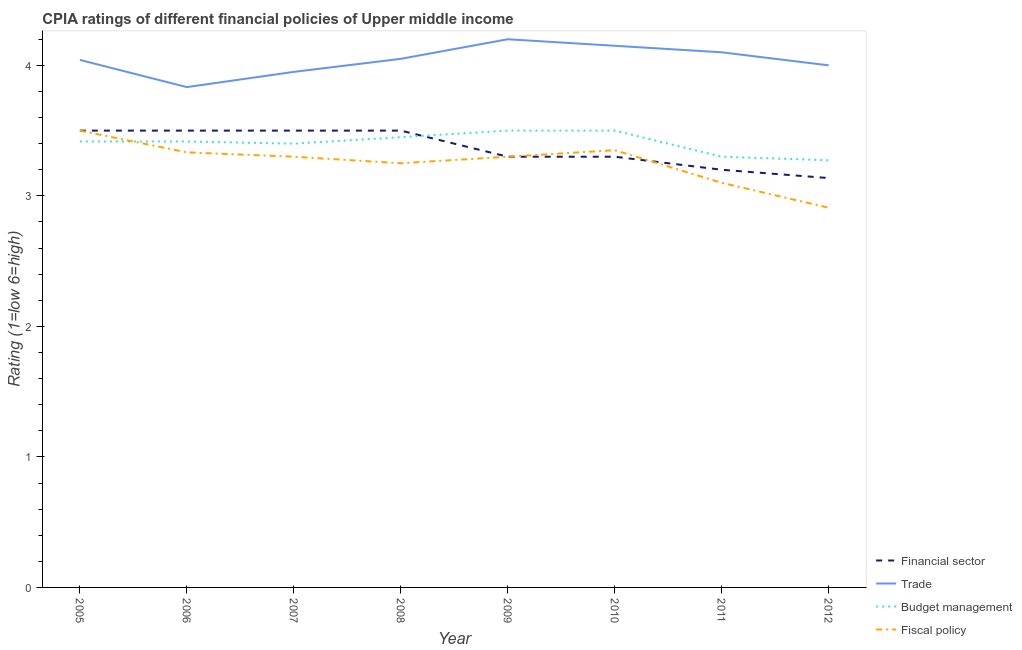Does the line corresponding to cpia rating of financial sector intersect with the line corresponding to cpia rating of budget management?
Your answer should be very brief. Yes. What is the cpia rating of fiscal policy in 2007?
Offer a very short reply. 3.3. Across all years, what is the maximum cpia rating of financial sector?
Your answer should be very brief. 3.5. Across all years, what is the minimum cpia rating of trade?
Make the answer very short. 3.83. What is the total cpia rating of budget management in the graph?
Your answer should be very brief. 27.26. What is the difference between the cpia rating of fiscal policy in 2010 and that in 2012?
Give a very brief answer. 0.44. What is the difference between the cpia rating of budget management in 2010 and the cpia rating of trade in 2008?
Your answer should be very brief. -0.55. What is the average cpia rating of financial sector per year?
Provide a short and direct response. 3.37. In the year 2010, what is the difference between the cpia rating of trade and cpia rating of financial sector?
Give a very brief answer. 0.85. In how many years, is the cpia rating of trade greater than 1.6?
Make the answer very short. 8. What is the ratio of the cpia rating of fiscal policy in 2005 to that in 2011?
Provide a succinct answer. 1.13. What is the difference between the highest and the second highest cpia rating of fiscal policy?
Your response must be concise. 0.15. What is the difference between the highest and the lowest cpia rating of fiscal policy?
Your response must be concise. 0.59. Is it the case that in every year, the sum of the cpia rating of financial sector and cpia rating of trade is greater than the cpia rating of budget management?
Your answer should be compact. Yes. Does the cpia rating of financial sector monotonically increase over the years?
Provide a succinct answer. No. How many lines are there?
Your answer should be very brief. 4. How many years are there in the graph?
Provide a succinct answer. 8. Where does the legend appear in the graph?
Your answer should be compact. Bottom right. How many legend labels are there?
Keep it short and to the point. 4. What is the title of the graph?
Keep it short and to the point. CPIA ratings of different financial policies of Upper middle income. What is the label or title of the X-axis?
Provide a succinct answer. Year. What is the Rating (1=low 6=high) in Trade in 2005?
Keep it short and to the point. 4.04. What is the Rating (1=low 6=high) in Budget management in 2005?
Offer a very short reply. 3.42. What is the Rating (1=low 6=high) in Trade in 2006?
Ensure brevity in your answer.  3.83. What is the Rating (1=low 6=high) in Budget management in 2006?
Provide a short and direct response. 3.42. What is the Rating (1=low 6=high) of Fiscal policy in 2006?
Give a very brief answer. 3.33. What is the Rating (1=low 6=high) in Financial sector in 2007?
Provide a short and direct response. 3.5. What is the Rating (1=low 6=high) in Trade in 2007?
Your response must be concise. 3.95. What is the Rating (1=low 6=high) in Budget management in 2007?
Provide a short and direct response. 3.4. What is the Rating (1=low 6=high) in Fiscal policy in 2007?
Keep it short and to the point. 3.3. What is the Rating (1=low 6=high) in Financial sector in 2008?
Offer a very short reply. 3.5. What is the Rating (1=low 6=high) in Trade in 2008?
Your answer should be very brief. 4.05. What is the Rating (1=low 6=high) in Budget management in 2008?
Make the answer very short. 3.45. What is the Rating (1=low 6=high) in Financial sector in 2010?
Provide a succinct answer. 3.3. What is the Rating (1=low 6=high) of Trade in 2010?
Offer a terse response. 4.15. What is the Rating (1=low 6=high) in Fiscal policy in 2010?
Keep it short and to the point. 3.35. What is the Rating (1=low 6=high) in Fiscal policy in 2011?
Your answer should be very brief. 3.1. What is the Rating (1=low 6=high) of Financial sector in 2012?
Provide a short and direct response. 3.14. What is the Rating (1=low 6=high) in Trade in 2012?
Keep it short and to the point. 4. What is the Rating (1=low 6=high) of Budget management in 2012?
Offer a very short reply. 3.27. What is the Rating (1=low 6=high) in Fiscal policy in 2012?
Your answer should be compact. 2.91. Across all years, what is the maximum Rating (1=low 6=high) of Trade?
Your response must be concise. 4.2. Across all years, what is the minimum Rating (1=low 6=high) of Financial sector?
Offer a very short reply. 3.14. Across all years, what is the minimum Rating (1=low 6=high) of Trade?
Your answer should be compact. 3.83. Across all years, what is the minimum Rating (1=low 6=high) of Budget management?
Provide a succinct answer. 3.27. Across all years, what is the minimum Rating (1=low 6=high) in Fiscal policy?
Your answer should be very brief. 2.91. What is the total Rating (1=low 6=high) in Financial sector in the graph?
Your answer should be very brief. 26.94. What is the total Rating (1=low 6=high) of Trade in the graph?
Provide a succinct answer. 32.33. What is the total Rating (1=low 6=high) in Budget management in the graph?
Offer a terse response. 27.26. What is the total Rating (1=low 6=high) in Fiscal policy in the graph?
Your answer should be compact. 26.04. What is the difference between the Rating (1=low 6=high) of Trade in 2005 and that in 2006?
Provide a succinct answer. 0.21. What is the difference between the Rating (1=low 6=high) in Budget management in 2005 and that in 2006?
Your response must be concise. 0. What is the difference between the Rating (1=low 6=high) in Fiscal policy in 2005 and that in 2006?
Your response must be concise. 0.17. What is the difference between the Rating (1=low 6=high) of Financial sector in 2005 and that in 2007?
Offer a terse response. 0. What is the difference between the Rating (1=low 6=high) of Trade in 2005 and that in 2007?
Ensure brevity in your answer.  0.09. What is the difference between the Rating (1=low 6=high) in Budget management in 2005 and that in 2007?
Provide a succinct answer. 0.02. What is the difference between the Rating (1=low 6=high) of Fiscal policy in 2005 and that in 2007?
Offer a very short reply. 0.2. What is the difference between the Rating (1=low 6=high) of Trade in 2005 and that in 2008?
Your answer should be compact. -0.01. What is the difference between the Rating (1=low 6=high) in Budget management in 2005 and that in 2008?
Ensure brevity in your answer.  -0.03. What is the difference between the Rating (1=low 6=high) in Financial sector in 2005 and that in 2009?
Your answer should be compact. 0.2. What is the difference between the Rating (1=low 6=high) of Trade in 2005 and that in 2009?
Offer a very short reply. -0.16. What is the difference between the Rating (1=low 6=high) of Budget management in 2005 and that in 2009?
Your answer should be very brief. -0.08. What is the difference between the Rating (1=low 6=high) in Trade in 2005 and that in 2010?
Your response must be concise. -0.11. What is the difference between the Rating (1=low 6=high) of Budget management in 2005 and that in 2010?
Make the answer very short. -0.08. What is the difference between the Rating (1=low 6=high) of Financial sector in 2005 and that in 2011?
Make the answer very short. 0.3. What is the difference between the Rating (1=low 6=high) in Trade in 2005 and that in 2011?
Your answer should be very brief. -0.06. What is the difference between the Rating (1=low 6=high) in Budget management in 2005 and that in 2011?
Provide a succinct answer. 0.12. What is the difference between the Rating (1=low 6=high) in Fiscal policy in 2005 and that in 2011?
Your response must be concise. 0.4. What is the difference between the Rating (1=low 6=high) in Financial sector in 2005 and that in 2012?
Offer a terse response. 0.36. What is the difference between the Rating (1=low 6=high) in Trade in 2005 and that in 2012?
Offer a very short reply. 0.04. What is the difference between the Rating (1=low 6=high) in Budget management in 2005 and that in 2012?
Your answer should be compact. 0.14. What is the difference between the Rating (1=low 6=high) in Fiscal policy in 2005 and that in 2012?
Provide a succinct answer. 0.59. What is the difference between the Rating (1=low 6=high) of Trade in 2006 and that in 2007?
Offer a very short reply. -0.12. What is the difference between the Rating (1=low 6=high) of Budget management in 2006 and that in 2007?
Offer a terse response. 0.02. What is the difference between the Rating (1=low 6=high) of Fiscal policy in 2006 and that in 2007?
Give a very brief answer. 0.03. What is the difference between the Rating (1=low 6=high) of Financial sector in 2006 and that in 2008?
Offer a terse response. 0. What is the difference between the Rating (1=low 6=high) in Trade in 2006 and that in 2008?
Offer a terse response. -0.22. What is the difference between the Rating (1=low 6=high) of Budget management in 2006 and that in 2008?
Your answer should be compact. -0.03. What is the difference between the Rating (1=low 6=high) of Fiscal policy in 2006 and that in 2008?
Offer a very short reply. 0.08. What is the difference between the Rating (1=low 6=high) of Financial sector in 2006 and that in 2009?
Give a very brief answer. 0.2. What is the difference between the Rating (1=low 6=high) in Trade in 2006 and that in 2009?
Your answer should be very brief. -0.37. What is the difference between the Rating (1=low 6=high) of Budget management in 2006 and that in 2009?
Make the answer very short. -0.08. What is the difference between the Rating (1=low 6=high) in Financial sector in 2006 and that in 2010?
Keep it short and to the point. 0.2. What is the difference between the Rating (1=low 6=high) of Trade in 2006 and that in 2010?
Your answer should be compact. -0.32. What is the difference between the Rating (1=low 6=high) of Budget management in 2006 and that in 2010?
Your answer should be very brief. -0.08. What is the difference between the Rating (1=low 6=high) in Fiscal policy in 2006 and that in 2010?
Keep it short and to the point. -0.02. What is the difference between the Rating (1=low 6=high) in Financial sector in 2006 and that in 2011?
Offer a terse response. 0.3. What is the difference between the Rating (1=low 6=high) of Trade in 2006 and that in 2011?
Give a very brief answer. -0.27. What is the difference between the Rating (1=low 6=high) of Budget management in 2006 and that in 2011?
Offer a very short reply. 0.12. What is the difference between the Rating (1=low 6=high) in Fiscal policy in 2006 and that in 2011?
Your answer should be very brief. 0.23. What is the difference between the Rating (1=low 6=high) in Financial sector in 2006 and that in 2012?
Your answer should be compact. 0.36. What is the difference between the Rating (1=low 6=high) of Trade in 2006 and that in 2012?
Your response must be concise. -0.17. What is the difference between the Rating (1=low 6=high) of Budget management in 2006 and that in 2012?
Offer a very short reply. 0.14. What is the difference between the Rating (1=low 6=high) in Fiscal policy in 2006 and that in 2012?
Your answer should be very brief. 0.42. What is the difference between the Rating (1=low 6=high) in Financial sector in 2007 and that in 2008?
Make the answer very short. 0. What is the difference between the Rating (1=low 6=high) in Budget management in 2007 and that in 2008?
Your answer should be compact. -0.05. What is the difference between the Rating (1=low 6=high) in Financial sector in 2007 and that in 2009?
Ensure brevity in your answer.  0.2. What is the difference between the Rating (1=low 6=high) in Budget management in 2007 and that in 2009?
Keep it short and to the point. -0.1. What is the difference between the Rating (1=low 6=high) of Financial sector in 2007 and that in 2010?
Your answer should be very brief. 0.2. What is the difference between the Rating (1=low 6=high) of Trade in 2007 and that in 2010?
Offer a terse response. -0.2. What is the difference between the Rating (1=low 6=high) of Financial sector in 2007 and that in 2011?
Your response must be concise. 0.3. What is the difference between the Rating (1=low 6=high) in Trade in 2007 and that in 2011?
Your answer should be very brief. -0.15. What is the difference between the Rating (1=low 6=high) in Fiscal policy in 2007 and that in 2011?
Provide a succinct answer. 0.2. What is the difference between the Rating (1=low 6=high) in Financial sector in 2007 and that in 2012?
Offer a very short reply. 0.36. What is the difference between the Rating (1=low 6=high) of Trade in 2007 and that in 2012?
Ensure brevity in your answer.  -0.05. What is the difference between the Rating (1=low 6=high) of Budget management in 2007 and that in 2012?
Offer a very short reply. 0.13. What is the difference between the Rating (1=low 6=high) in Fiscal policy in 2007 and that in 2012?
Your answer should be compact. 0.39. What is the difference between the Rating (1=low 6=high) in Financial sector in 2008 and that in 2009?
Make the answer very short. 0.2. What is the difference between the Rating (1=low 6=high) in Trade in 2008 and that in 2009?
Your answer should be compact. -0.15. What is the difference between the Rating (1=low 6=high) in Fiscal policy in 2008 and that in 2009?
Your response must be concise. -0.05. What is the difference between the Rating (1=low 6=high) in Financial sector in 2008 and that in 2010?
Ensure brevity in your answer.  0.2. What is the difference between the Rating (1=low 6=high) of Budget management in 2008 and that in 2010?
Keep it short and to the point. -0.05. What is the difference between the Rating (1=low 6=high) in Fiscal policy in 2008 and that in 2010?
Make the answer very short. -0.1. What is the difference between the Rating (1=low 6=high) in Financial sector in 2008 and that in 2011?
Offer a very short reply. 0.3. What is the difference between the Rating (1=low 6=high) in Trade in 2008 and that in 2011?
Offer a terse response. -0.05. What is the difference between the Rating (1=low 6=high) in Budget management in 2008 and that in 2011?
Ensure brevity in your answer.  0.15. What is the difference between the Rating (1=low 6=high) in Fiscal policy in 2008 and that in 2011?
Your answer should be compact. 0.15. What is the difference between the Rating (1=low 6=high) in Financial sector in 2008 and that in 2012?
Provide a short and direct response. 0.36. What is the difference between the Rating (1=low 6=high) of Budget management in 2008 and that in 2012?
Ensure brevity in your answer.  0.18. What is the difference between the Rating (1=low 6=high) in Fiscal policy in 2008 and that in 2012?
Your answer should be very brief. 0.34. What is the difference between the Rating (1=low 6=high) of Financial sector in 2009 and that in 2010?
Your answer should be compact. 0. What is the difference between the Rating (1=low 6=high) of Budget management in 2009 and that in 2010?
Ensure brevity in your answer.  0. What is the difference between the Rating (1=low 6=high) of Fiscal policy in 2009 and that in 2010?
Provide a succinct answer. -0.05. What is the difference between the Rating (1=low 6=high) in Fiscal policy in 2009 and that in 2011?
Ensure brevity in your answer.  0.2. What is the difference between the Rating (1=low 6=high) of Financial sector in 2009 and that in 2012?
Provide a short and direct response. 0.16. What is the difference between the Rating (1=low 6=high) of Trade in 2009 and that in 2012?
Your answer should be very brief. 0.2. What is the difference between the Rating (1=low 6=high) of Budget management in 2009 and that in 2012?
Your answer should be compact. 0.23. What is the difference between the Rating (1=low 6=high) in Fiscal policy in 2009 and that in 2012?
Ensure brevity in your answer.  0.39. What is the difference between the Rating (1=low 6=high) in Financial sector in 2010 and that in 2011?
Give a very brief answer. 0.1. What is the difference between the Rating (1=low 6=high) in Trade in 2010 and that in 2011?
Offer a very short reply. 0.05. What is the difference between the Rating (1=low 6=high) in Budget management in 2010 and that in 2011?
Give a very brief answer. 0.2. What is the difference between the Rating (1=low 6=high) of Fiscal policy in 2010 and that in 2011?
Give a very brief answer. 0.25. What is the difference between the Rating (1=low 6=high) in Financial sector in 2010 and that in 2012?
Ensure brevity in your answer.  0.16. What is the difference between the Rating (1=low 6=high) in Trade in 2010 and that in 2012?
Your answer should be very brief. 0.15. What is the difference between the Rating (1=low 6=high) in Budget management in 2010 and that in 2012?
Keep it short and to the point. 0.23. What is the difference between the Rating (1=low 6=high) in Fiscal policy in 2010 and that in 2012?
Your response must be concise. 0.44. What is the difference between the Rating (1=low 6=high) of Financial sector in 2011 and that in 2012?
Give a very brief answer. 0.06. What is the difference between the Rating (1=low 6=high) of Trade in 2011 and that in 2012?
Provide a succinct answer. 0.1. What is the difference between the Rating (1=low 6=high) in Budget management in 2011 and that in 2012?
Your response must be concise. 0.03. What is the difference between the Rating (1=low 6=high) of Fiscal policy in 2011 and that in 2012?
Provide a short and direct response. 0.19. What is the difference between the Rating (1=low 6=high) of Financial sector in 2005 and the Rating (1=low 6=high) of Trade in 2006?
Provide a short and direct response. -0.33. What is the difference between the Rating (1=low 6=high) of Financial sector in 2005 and the Rating (1=low 6=high) of Budget management in 2006?
Keep it short and to the point. 0.08. What is the difference between the Rating (1=low 6=high) in Financial sector in 2005 and the Rating (1=low 6=high) in Fiscal policy in 2006?
Ensure brevity in your answer.  0.17. What is the difference between the Rating (1=low 6=high) of Trade in 2005 and the Rating (1=low 6=high) of Fiscal policy in 2006?
Offer a very short reply. 0.71. What is the difference between the Rating (1=low 6=high) in Budget management in 2005 and the Rating (1=low 6=high) in Fiscal policy in 2006?
Give a very brief answer. 0.08. What is the difference between the Rating (1=low 6=high) in Financial sector in 2005 and the Rating (1=low 6=high) in Trade in 2007?
Offer a very short reply. -0.45. What is the difference between the Rating (1=low 6=high) of Trade in 2005 and the Rating (1=low 6=high) of Budget management in 2007?
Your answer should be very brief. 0.64. What is the difference between the Rating (1=low 6=high) in Trade in 2005 and the Rating (1=low 6=high) in Fiscal policy in 2007?
Your answer should be very brief. 0.74. What is the difference between the Rating (1=low 6=high) of Budget management in 2005 and the Rating (1=low 6=high) of Fiscal policy in 2007?
Offer a terse response. 0.12. What is the difference between the Rating (1=low 6=high) of Financial sector in 2005 and the Rating (1=low 6=high) of Trade in 2008?
Offer a terse response. -0.55. What is the difference between the Rating (1=low 6=high) in Financial sector in 2005 and the Rating (1=low 6=high) in Budget management in 2008?
Provide a short and direct response. 0.05. What is the difference between the Rating (1=low 6=high) of Trade in 2005 and the Rating (1=low 6=high) of Budget management in 2008?
Ensure brevity in your answer.  0.59. What is the difference between the Rating (1=low 6=high) of Trade in 2005 and the Rating (1=low 6=high) of Fiscal policy in 2008?
Your answer should be compact. 0.79. What is the difference between the Rating (1=low 6=high) in Budget management in 2005 and the Rating (1=low 6=high) in Fiscal policy in 2008?
Provide a succinct answer. 0.17. What is the difference between the Rating (1=low 6=high) in Financial sector in 2005 and the Rating (1=low 6=high) in Trade in 2009?
Keep it short and to the point. -0.7. What is the difference between the Rating (1=low 6=high) in Trade in 2005 and the Rating (1=low 6=high) in Budget management in 2009?
Keep it short and to the point. 0.54. What is the difference between the Rating (1=low 6=high) in Trade in 2005 and the Rating (1=low 6=high) in Fiscal policy in 2009?
Keep it short and to the point. 0.74. What is the difference between the Rating (1=low 6=high) in Budget management in 2005 and the Rating (1=low 6=high) in Fiscal policy in 2009?
Provide a short and direct response. 0.12. What is the difference between the Rating (1=low 6=high) of Financial sector in 2005 and the Rating (1=low 6=high) of Trade in 2010?
Provide a succinct answer. -0.65. What is the difference between the Rating (1=low 6=high) of Financial sector in 2005 and the Rating (1=low 6=high) of Fiscal policy in 2010?
Keep it short and to the point. 0.15. What is the difference between the Rating (1=low 6=high) of Trade in 2005 and the Rating (1=low 6=high) of Budget management in 2010?
Offer a very short reply. 0.54. What is the difference between the Rating (1=low 6=high) in Trade in 2005 and the Rating (1=low 6=high) in Fiscal policy in 2010?
Offer a terse response. 0.69. What is the difference between the Rating (1=low 6=high) in Budget management in 2005 and the Rating (1=low 6=high) in Fiscal policy in 2010?
Your answer should be compact. 0.07. What is the difference between the Rating (1=low 6=high) of Financial sector in 2005 and the Rating (1=low 6=high) of Trade in 2011?
Ensure brevity in your answer.  -0.6. What is the difference between the Rating (1=low 6=high) of Financial sector in 2005 and the Rating (1=low 6=high) of Budget management in 2011?
Make the answer very short. 0.2. What is the difference between the Rating (1=low 6=high) in Trade in 2005 and the Rating (1=low 6=high) in Budget management in 2011?
Provide a succinct answer. 0.74. What is the difference between the Rating (1=low 6=high) in Trade in 2005 and the Rating (1=low 6=high) in Fiscal policy in 2011?
Ensure brevity in your answer.  0.94. What is the difference between the Rating (1=low 6=high) in Budget management in 2005 and the Rating (1=low 6=high) in Fiscal policy in 2011?
Offer a terse response. 0.32. What is the difference between the Rating (1=low 6=high) of Financial sector in 2005 and the Rating (1=low 6=high) of Budget management in 2012?
Offer a terse response. 0.23. What is the difference between the Rating (1=low 6=high) of Financial sector in 2005 and the Rating (1=low 6=high) of Fiscal policy in 2012?
Offer a terse response. 0.59. What is the difference between the Rating (1=low 6=high) in Trade in 2005 and the Rating (1=low 6=high) in Budget management in 2012?
Offer a very short reply. 0.77. What is the difference between the Rating (1=low 6=high) in Trade in 2005 and the Rating (1=low 6=high) in Fiscal policy in 2012?
Ensure brevity in your answer.  1.13. What is the difference between the Rating (1=low 6=high) in Budget management in 2005 and the Rating (1=low 6=high) in Fiscal policy in 2012?
Offer a terse response. 0.51. What is the difference between the Rating (1=low 6=high) of Financial sector in 2006 and the Rating (1=low 6=high) of Trade in 2007?
Your response must be concise. -0.45. What is the difference between the Rating (1=low 6=high) of Financial sector in 2006 and the Rating (1=low 6=high) of Fiscal policy in 2007?
Offer a very short reply. 0.2. What is the difference between the Rating (1=low 6=high) in Trade in 2006 and the Rating (1=low 6=high) in Budget management in 2007?
Keep it short and to the point. 0.43. What is the difference between the Rating (1=low 6=high) in Trade in 2006 and the Rating (1=low 6=high) in Fiscal policy in 2007?
Keep it short and to the point. 0.53. What is the difference between the Rating (1=low 6=high) in Budget management in 2006 and the Rating (1=low 6=high) in Fiscal policy in 2007?
Your response must be concise. 0.12. What is the difference between the Rating (1=low 6=high) in Financial sector in 2006 and the Rating (1=low 6=high) in Trade in 2008?
Keep it short and to the point. -0.55. What is the difference between the Rating (1=low 6=high) of Trade in 2006 and the Rating (1=low 6=high) of Budget management in 2008?
Give a very brief answer. 0.38. What is the difference between the Rating (1=low 6=high) of Trade in 2006 and the Rating (1=low 6=high) of Fiscal policy in 2008?
Make the answer very short. 0.58. What is the difference between the Rating (1=low 6=high) of Budget management in 2006 and the Rating (1=low 6=high) of Fiscal policy in 2008?
Ensure brevity in your answer.  0.17. What is the difference between the Rating (1=low 6=high) of Financial sector in 2006 and the Rating (1=low 6=high) of Fiscal policy in 2009?
Provide a succinct answer. 0.2. What is the difference between the Rating (1=low 6=high) of Trade in 2006 and the Rating (1=low 6=high) of Fiscal policy in 2009?
Provide a succinct answer. 0.53. What is the difference between the Rating (1=low 6=high) of Budget management in 2006 and the Rating (1=low 6=high) of Fiscal policy in 2009?
Your response must be concise. 0.12. What is the difference between the Rating (1=low 6=high) of Financial sector in 2006 and the Rating (1=low 6=high) of Trade in 2010?
Provide a short and direct response. -0.65. What is the difference between the Rating (1=low 6=high) of Financial sector in 2006 and the Rating (1=low 6=high) of Fiscal policy in 2010?
Offer a very short reply. 0.15. What is the difference between the Rating (1=low 6=high) of Trade in 2006 and the Rating (1=low 6=high) of Fiscal policy in 2010?
Your answer should be compact. 0.48. What is the difference between the Rating (1=low 6=high) of Budget management in 2006 and the Rating (1=low 6=high) of Fiscal policy in 2010?
Offer a very short reply. 0.07. What is the difference between the Rating (1=low 6=high) in Trade in 2006 and the Rating (1=low 6=high) in Budget management in 2011?
Offer a terse response. 0.53. What is the difference between the Rating (1=low 6=high) in Trade in 2006 and the Rating (1=low 6=high) in Fiscal policy in 2011?
Provide a short and direct response. 0.73. What is the difference between the Rating (1=low 6=high) in Budget management in 2006 and the Rating (1=low 6=high) in Fiscal policy in 2011?
Offer a very short reply. 0.32. What is the difference between the Rating (1=low 6=high) in Financial sector in 2006 and the Rating (1=low 6=high) in Trade in 2012?
Your response must be concise. -0.5. What is the difference between the Rating (1=low 6=high) of Financial sector in 2006 and the Rating (1=low 6=high) of Budget management in 2012?
Give a very brief answer. 0.23. What is the difference between the Rating (1=low 6=high) in Financial sector in 2006 and the Rating (1=low 6=high) in Fiscal policy in 2012?
Give a very brief answer. 0.59. What is the difference between the Rating (1=low 6=high) in Trade in 2006 and the Rating (1=low 6=high) in Budget management in 2012?
Keep it short and to the point. 0.56. What is the difference between the Rating (1=low 6=high) of Trade in 2006 and the Rating (1=low 6=high) of Fiscal policy in 2012?
Give a very brief answer. 0.92. What is the difference between the Rating (1=low 6=high) in Budget management in 2006 and the Rating (1=low 6=high) in Fiscal policy in 2012?
Give a very brief answer. 0.51. What is the difference between the Rating (1=low 6=high) of Financial sector in 2007 and the Rating (1=low 6=high) of Trade in 2008?
Your response must be concise. -0.55. What is the difference between the Rating (1=low 6=high) of Trade in 2007 and the Rating (1=low 6=high) of Fiscal policy in 2008?
Your answer should be very brief. 0.7. What is the difference between the Rating (1=low 6=high) in Budget management in 2007 and the Rating (1=low 6=high) in Fiscal policy in 2008?
Provide a succinct answer. 0.15. What is the difference between the Rating (1=low 6=high) of Financial sector in 2007 and the Rating (1=low 6=high) of Trade in 2009?
Give a very brief answer. -0.7. What is the difference between the Rating (1=low 6=high) in Trade in 2007 and the Rating (1=low 6=high) in Budget management in 2009?
Provide a succinct answer. 0.45. What is the difference between the Rating (1=low 6=high) in Trade in 2007 and the Rating (1=low 6=high) in Fiscal policy in 2009?
Provide a short and direct response. 0.65. What is the difference between the Rating (1=low 6=high) of Financial sector in 2007 and the Rating (1=low 6=high) of Trade in 2010?
Your answer should be compact. -0.65. What is the difference between the Rating (1=low 6=high) in Trade in 2007 and the Rating (1=low 6=high) in Budget management in 2010?
Your response must be concise. 0.45. What is the difference between the Rating (1=low 6=high) of Trade in 2007 and the Rating (1=low 6=high) of Fiscal policy in 2010?
Ensure brevity in your answer.  0.6. What is the difference between the Rating (1=low 6=high) in Financial sector in 2007 and the Rating (1=low 6=high) in Budget management in 2011?
Make the answer very short. 0.2. What is the difference between the Rating (1=low 6=high) in Financial sector in 2007 and the Rating (1=low 6=high) in Fiscal policy in 2011?
Offer a terse response. 0.4. What is the difference between the Rating (1=low 6=high) of Trade in 2007 and the Rating (1=low 6=high) of Budget management in 2011?
Offer a terse response. 0.65. What is the difference between the Rating (1=low 6=high) of Trade in 2007 and the Rating (1=low 6=high) of Fiscal policy in 2011?
Your answer should be compact. 0.85. What is the difference between the Rating (1=low 6=high) in Budget management in 2007 and the Rating (1=low 6=high) in Fiscal policy in 2011?
Offer a terse response. 0.3. What is the difference between the Rating (1=low 6=high) in Financial sector in 2007 and the Rating (1=low 6=high) in Trade in 2012?
Offer a very short reply. -0.5. What is the difference between the Rating (1=low 6=high) of Financial sector in 2007 and the Rating (1=low 6=high) of Budget management in 2012?
Your response must be concise. 0.23. What is the difference between the Rating (1=low 6=high) in Financial sector in 2007 and the Rating (1=low 6=high) in Fiscal policy in 2012?
Your response must be concise. 0.59. What is the difference between the Rating (1=low 6=high) of Trade in 2007 and the Rating (1=low 6=high) of Budget management in 2012?
Keep it short and to the point. 0.68. What is the difference between the Rating (1=low 6=high) of Trade in 2007 and the Rating (1=low 6=high) of Fiscal policy in 2012?
Keep it short and to the point. 1.04. What is the difference between the Rating (1=low 6=high) of Budget management in 2007 and the Rating (1=low 6=high) of Fiscal policy in 2012?
Offer a very short reply. 0.49. What is the difference between the Rating (1=low 6=high) of Financial sector in 2008 and the Rating (1=low 6=high) of Budget management in 2009?
Your answer should be very brief. 0. What is the difference between the Rating (1=low 6=high) of Trade in 2008 and the Rating (1=low 6=high) of Budget management in 2009?
Provide a short and direct response. 0.55. What is the difference between the Rating (1=low 6=high) in Financial sector in 2008 and the Rating (1=low 6=high) in Trade in 2010?
Your answer should be compact. -0.65. What is the difference between the Rating (1=low 6=high) in Financial sector in 2008 and the Rating (1=low 6=high) in Fiscal policy in 2010?
Your response must be concise. 0.15. What is the difference between the Rating (1=low 6=high) of Trade in 2008 and the Rating (1=low 6=high) of Budget management in 2010?
Your answer should be very brief. 0.55. What is the difference between the Rating (1=low 6=high) of Financial sector in 2008 and the Rating (1=low 6=high) of Budget management in 2011?
Offer a very short reply. 0.2. What is the difference between the Rating (1=low 6=high) in Financial sector in 2008 and the Rating (1=low 6=high) in Fiscal policy in 2011?
Your answer should be very brief. 0.4. What is the difference between the Rating (1=low 6=high) in Financial sector in 2008 and the Rating (1=low 6=high) in Budget management in 2012?
Give a very brief answer. 0.23. What is the difference between the Rating (1=low 6=high) of Financial sector in 2008 and the Rating (1=low 6=high) of Fiscal policy in 2012?
Make the answer very short. 0.59. What is the difference between the Rating (1=low 6=high) of Trade in 2008 and the Rating (1=low 6=high) of Budget management in 2012?
Ensure brevity in your answer.  0.78. What is the difference between the Rating (1=low 6=high) in Trade in 2008 and the Rating (1=low 6=high) in Fiscal policy in 2012?
Keep it short and to the point. 1.14. What is the difference between the Rating (1=low 6=high) in Budget management in 2008 and the Rating (1=low 6=high) in Fiscal policy in 2012?
Offer a very short reply. 0.54. What is the difference between the Rating (1=low 6=high) of Financial sector in 2009 and the Rating (1=low 6=high) of Trade in 2010?
Provide a succinct answer. -0.85. What is the difference between the Rating (1=low 6=high) in Financial sector in 2009 and the Rating (1=low 6=high) in Fiscal policy in 2010?
Your response must be concise. -0.05. What is the difference between the Rating (1=low 6=high) in Trade in 2009 and the Rating (1=low 6=high) in Budget management in 2010?
Provide a succinct answer. 0.7. What is the difference between the Rating (1=low 6=high) in Trade in 2009 and the Rating (1=low 6=high) in Fiscal policy in 2010?
Provide a short and direct response. 0.85. What is the difference between the Rating (1=low 6=high) in Financial sector in 2009 and the Rating (1=low 6=high) in Trade in 2011?
Your answer should be compact. -0.8. What is the difference between the Rating (1=low 6=high) of Financial sector in 2009 and the Rating (1=low 6=high) of Fiscal policy in 2011?
Keep it short and to the point. 0.2. What is the difference between the Rating (1=low 6=high) of Trade in 2009 and the Rating (1=low 6=high) of Budget management in 2011?
Make the answer very short. 0.9. What is the difference between the Rating (1=low 6=high) of Trade in 2009 and the Rating (1=low 6=high) of Fiscal policy in 2011?
Keep it short and to the point. 1.1. What is the difference between the Rating (1=low 6=high) in Budget management in 2009 and the Rating (1=low 6=high) in Fiscal policy in 2011?
Provide a succinct answer. 0.4. What is the difference between the Rating (1=low 6=high) in Financial sector in 2009 and the Rating (1=low 6=high) in Trade in 2012?
Offer a terse response. -0.7. What is the difference between the Rating (1=low 6=high) of Financial sector in 2009 and the Rating (1=low 6=high) of Budget management in 2012?
Your answer should be compact. 0.03. What is the difference between the Rating (1=low 6=high) of Financial sector in 2009 and the Rating (1=low 6=high) of Fiscal policy in 2012?
Give a very brief answer. 0.39. What is the difference between the Rating (1=low 6=high) in Trade in 2009 and the Rating (1=low 6=high) in Budget management in 2012?
Offer a very short reply. 0.93. What is the difference between the Rating (1=low 6=high) in Trade in 2009 and the Rating (1=low 6=high) in Fiscal policy in 2012?
Make the answer very short. 1.29. What is the difference between the Rating (1=low 6=high) in Budget management in 2009 and the Rating (1=low 6=high) in Fiscal policy in 2012?
Make the answer very short. 0.59. What is the difference between the Rating (1=low 6=high) of Financial sector in 2010 and the Rating (1=low 6=high) of Budget management in 2011?
Your answer should be very brief. 0. What is the difference between the Rating (1=low 6=high) of Financial sector in 2010 and the Rating (1=low 6=high) of Fiscal policy in 2011?
Your answer should be compact. 0.2. What is the difference between the Rating (1=low 6=high) in Trade in 2010 and the Rating (1=low 6=high) in Budget management in 2011?
Offer a very short reply. 0.85. What is the difference between the Rating (1=low 6=high) in Financial sector in 2010 and the Rating (1=low 6=high) in Trade in 2012?
Offer a terse response. -0.7. What is the difference between the Rating (1=low 6=high) in Financial sector in 2010 and the Rating (1=low 6=high) in Budget management in 2012?
Give a very brief answer. 0.03. What is the difference between the Rating (1=low 6=high) of Financial sector in 2010 and the Rating (1=low 6=high) of Fiscal policy in 2012?
Offer a terse response. 0.39. What is the difference between the Rating (1=low 6=high) in Trade in 2010 and the Rating (1=low 6=high) in Budget management in 2012?
Offer a very short reply. 0.88. What is the difference between the Rating (1=low 6=high) in Trade in 2010 and the Rating (1=low 6=high) in Fiscal policy in 2012?
Offer a very short reply. 1.24. What is the difference between the Rating (1=low 6=high) in Budget management in 2010 and the Rating (1=low 6=high) in Fiscal policy in 2012?
Ensure brevity in your answer.  0.59. What is the difference between the Rating (1=low 6=high) in Financial sector in 2011 and the Rating (1=low 6=high) in Budget management in 2012?
Provide a succinct answer. -0.07. What is the difference between the Rating (1=low 6=high) in Financial sector in 2011 and the Rating (1=low 6=high) in Fiscal policy in 2012?
Keep it short and to the point. 0.29. What is the difference between the Rating (1=low 6=high) in Trade in 2011 and the Rating (1=low 6=high) in Budget management in 2012?
Your answer should be compact. 0.83. What is the difference between the Rating (1=low 6=high) of Trade in 2011 and the Rating (1=low 6=high) of Fiscal policy in 2012?
Your answer should be very brief. 1.19. What is the difference between the Rating (1=low 6=high) in Budget management in 2011 and the Rating (1=low 6=high) in Fiscal policy in 2012?
Your response must be concise. 0.39. What is the average Rating (1=low 6=high) in Financial sector per year?
Offer a very short reply. 3.37. What is the average Rating (1=low 6=high) in Trade per year?
Your response must be concise. 4.04. What is the average Rating (1=low 6=high) in Budget management per year?
Your answer should be compact. 3.41. What is the average Rating (1=low 6=high) in Fiscal policy per year?
Provide a succinct answer. 3.26. In the year 2005, what is the difference between the Rating (1=low 6=high) of Financial sector and Rating (1=low 6=high) of Trade?
Provide a succinct answer. -0.54. In the year 2005, what is the difference between the Rating (1=low 6=high) of Financial sector and Rating (1=low 6=high) of Budget management?
Your answer should be very brief. 0.08. In the year 2005, what is the difference between the Rating (1=low 6=high) of Trade and Rating (1=low 6=high) of Fiscal policy?
Your response must be concise. 0.54. In the year 2005, what is the difference between the Rating (1=low 6=high) of Budget management and Rating (1=low 6=high) of Fiscal policy?
Your answer should be compact. -0.08. In the year 2006, what is the difference between the Rating (1=low 6=high) of Financial sector and Rating (1=low 6=high) of Budget management?
Ensure brevity in your answer.  0.08. In the year 2006, what is the difference between the Rating (1=low 6=high) in Financial sector and Rating (1=low 6=high) in Fiscal policy?
Provide a short and direct response. 0.17. In the year 2006, what is the difference between the Rating (1=low 6=high) of Trade and Rating (1=low 6=high) of Budget management?
Provide a succinct answer. 0.42. In the year 2006, what is the difference between the Rating (1=low 6=high) of Budget management and Rating (1=low 6=high) of Fiscal policy?
Your response must be concise. 0.08. In the year 2007, what is the difference between the Rating (1=low 6=high) in Financial sector and Rating (1=low 6=high) in Trade?
Your answer should be very brief. -0.45. In the year 2007, what is the difference between the Rating (1=low 6=high) in Trade and Rating (1=low 6=high) in Budget management?
Ensure brevity in your answer.  0.55. In the year 2007, what is the difference between the Rating (1=low 6=high) in Trade and Rating (1=low 6=high) in Fiscal policy?
Give a very brief answer. 0.65. In the year 2008, what is the difference between the Rating (1=low 6=high) of Financial sector and Rating (1=low 6=high) of Trade?
Your answer should be compact. -0.55. In the year 2008, what is the difference between the Rating (1=low 6=high) of Trade and Rating (1=low 6=high) of Fiscal policy?
Offer a very short reply. 0.8. In the year 2009, what is the difference between the Rating (1=low 6=high) of Financial sector and Rating (1=low 6=high) of Budget management?
Ensure brevity in your answer.  -0.2. In the year 2009, what is the difference between the Rating (1=low 6=high) in Financial sector and Rating (1=low 6=high) in Fiscal policy?
Your answer should be compact. 0. In the year 2009, what is the difference between the Rating (1=low 6=high) in Trade and Rating (1=low 6=high) in Fiscal policy?
Offer a very short reply. 0.9. In the year 2010, what is the difference between the Rating (1=low 6=high) in Financial sector and Rating (1=low 6=high) in Trade?
Your response must be concise. -0.85. In the year 2010, what is the difference between the Rating (1=low 6=high) of Financial sector and Rating (1=low 6=high) of Budget management?
Provide a short and direct response. -0.2. In the year 2010, what is the difference between the Rating (1=low 6=high) of Financial sector and Rating (1=low 6=high) of Fiscal policy?
Offer a terse response. -0.05. In the year 2010, what is the difference between the Rating (1=low 6=high) of Trade and Rating (1=low 6=high) of Budget management?
Provide a succinct answer. 0.65. In the year 2011, what is the difference between the Rating (1=low 6=high) in Financial sector and Rating (1=low 6=high) in Fiscal policy?
Make the answer very short. 0.1. In the year 2011, what is the difference between the Rating (1=low 6=high) of Trade and Rating (1=low 6=high) of Fiscal policy?
Make the answer very short. 1. In the year 2011, what is the difference between the Rating (1=low 6=high) in Budget management and Rating (1=low 6=high) in Fiscal policy?
Offer a terse response. 0.2. In the year 2012, what is the difference between the Rating (1=low 6=high) of Financial sector and Rating (1=low 6=high) of Trade?
Offer a terse response. -0.86. In the year 2012, what is the difference between the Rating (1=low 6=high) in Financial sector and Rating (1=low 6=high) in Budget management?
Ensure brevity in your answer.  -0.14. In the year 2012, what is the difference between the Rating (1=low 6=high) of Financial sector and Rating (1=low 6=high) of Fiscal policy?
Keep it short and to the point. 0.23. In the year 2012, what is the difference between the Rating (1=low 6=high) in Trade and Rating (1=low 6=high) in Budget management?
Your response must be concise. 0.73. In the year 2012, what is the difference between the Rating (1=low 6=high) of Budget management and Rating (1=low 6=high) of Fiscal policy?
Your response must be concise. 0.36. What is the ratio of the Rating (1=low 6=high) of Financial sector in 2005 to that in 2006?
Provide a succinct answer. 1. What is the ratio of the Rating (1=low 6=high) in Trade in 2005 to that in 2006?
Your answer should be very brief. 1.05. What is the ratio of the Rating (1=low 6=high) of Budget management in 2005 to that in 2006?
Offer a very short reply. 1. What is the ratio of the Rating (1=low 6=high) in Fiscal policy in 2005 to that in 2006?
Your response must be concise. 1.05. What is the ratio of the Rating (1=low 6=high) of Trade in 2005 to that in 2007?
Offer a terse response. 1.02. What is the ratio of the Rating (1=low 6=high) in Budget management in 2005 to that in 2007?
Provide a short and direct response. 1. What is the ratio of the Rating (1=low 6=high) of Fiscal policy in 2005 to that in 2007?
Your response must be concise. 1.06. What is the ratio of the Rating (1=low 6=high) of Trade in 2005 to that in 2008?
Provide a short and direct response. 1. What is the ratio of the Rating (1=low 6=high) of Budget management in 2005 to that in 2008?
Give a very brief answer. 0.99. What is the ratio of the Rating (1=low 6=high) of Financial sector in 2005 to that in 2009?
Ensure brevity in your answer.  1.06. What is the ratio of the Rating (1=low 6=high) in Trade in 2005 to that in 2009?
Give a very brief answer. 0.96. What is the ratio of the Rating (1=low 6=high) in Budget management in 2005 to that in 2009?
Your answer should be very brief. 0.98. What is the ratio of the Rating (1=low 6=high) in Fiscal policy in 2005 to that in 2009?
Offer a terse response. 1.06. What is the ratio of the Rating (1=low 6=high) in Financial sector in 2005 to that in 2010?
Your response must be concise. 1.06. What is the ratio of the Rating (1=low 6=high) of Trade in 2005 to that in 2010?
Your answer should be compact. 0.97. What is the ratio of the Rating (1=low 6=high) of Budget management in 2005 to that in 2010?
Provide a succinct answer. 0.98. What is the ratio of the Rating (1=low 6=high) of Fiscal policy in 2005 to that in 2010?
Ensure brevity in your answer.  1.04. What is the ratio of the Rating (1=low 6=high) in Financial sector in 2005 to that in 2011?
Your response must be concise. 1.09. What is the ratio of the Rating (1=low 6=high) in Trade in 2005 to that in 2011?
Provide a succinct answer. 0.99. What is the ratio of the Rating (1=low 6=high) in Budget management in 2005 to that in 2011?
Your answer should be very brief. 1.04. What is the ratio of the Rating (1=low 6=high) of Fiscal policy in 2005 to that in 2011?
Your answer should be very brief. 1.13. What is the ratio of the Rating (1=low 6=high) of Financial sector in 2005 to that in 2012?
Give a very brief answer. 1.12. What is the ratio of the Rating (1=low 6=high) in Trade in 2005 to that in 2012?
Your answer should be very brief. 1.01. What is the ratio of the Rating (1=low 6=high) of Budget management in 2005 to that in 2012?
Offer a terse response. 1.04. What is the ratio of the Rating (1=low 6=high) in Fiscal policy in 2005 to that in 2012?
Your answer should be compact. 1.2. What is the ratio of the Rating (1=low 6=high) of Trade in 2006 to that in 2007?
Offer a very short reply. 0.97. What is the ratio of the Rating (1=low 6=high) of Budget management in 2006 to that in 2007?
Offer a very short reply. 1. What is the ratio of the Rating (1=low 6=high) of Fiscal policy in 2006 to that in 2007?
Offer a very short reply. 1.01. What is the ratio of the Rating (1=low 6=high) of Trade in 2006 to that in 2008?
Provide a short and direct response. 0.95. What is the ratio of the Rating (1=low 6=high) of Budget management in 2006 to that in 2008?
Keep it short and to the point. 0.99. What is the ratio of the Rating (1=low 6=high) of Fiscal policy in 2006 to that in 2008?
Your answer should be very brief. 1.03. What is the ratio of the Rating (1=low 6=high) in Financial sector in 2006 to that in 2009?
Your answer should be very brief. 1.06. What is the ratio of the Rating (1=low 6=high) of Trade in 2006 to that in 2009?
Keep it short and to the point. 0.91. What is the ratio of the Rating (1=low 6=high) of Budget management in 2006 to that in 2009?
Your response must be concise. 0.98. What is the ratio of the Rating (1=low 6=high) in Financial sector in 2006 to that in 2010?
Keep it short and to the point. 1.06. What is the ratio of the Rating (1=low 6=high) in Trade in 2006 to that in 2010?
Provide a short and direct response. 0.92. What is the ratio of the Rating (1=low 6=high) in Budget management in 2006 to that in 2010?
Your response must be concise. 0.98. What is the ratio of the Rating (1=low 6=high) in Fiscal policy in 2006 to that in 2010?
Ensure brevity in your answer.  0.99. What is the ratio of the Rating (1=low 6=high) in Financial sector in 2006 to that in 2011?
Provide a short and direct response. 1.09. What is the ratio of the Rating (1=low 6=high) in Trade in 2006 to that in 2011?
Offer a very short reply. 0.94. What is the ratio of the Rating (1=low 6=high) in Budget management in 2006 to that in 2011?
Keep it short and to the point. 1.04. What is the ratio of the Rating (1=low 6=high) in Fiscal policy in 2006 to that in 2011?
Provide a succinct answer. 1.08. What is the ratio of the Rating (1=low 6=high) of Financial sector in 2006 to that in 2012?
Offer a very short reply. 1.12. What is the ratio of the Rating (1=low 6=high) in Trade in 2006 to that in 2012?
Provide a succinct answer. 0.96. What is the ratio of the Rating (1=low 6=high) in Budget management in 2006 to that in 2012?
Ensure brevity in your answer.  1.04. What is the ratio of the Rating (1=low 6=high) of Fiscal policy in 2006 to that in 2012?
Your answer should be compact. 1.15. What is the ratio of the Rating (1=low 6=high) of Trade in 2007 to that in 2008?
Your answer should be very brief. 0.98. What is the ratio of the Rating (1=low 6=high) of Budget management in 2007 to that in 2008?
Provide a succinct answer. 0.99. What is the ratio of the Rating (1=low 6=high) in Fiscal policy in 2007 to that in 2008?
Provide a succinct answer. 1.02. What is the ratio of the Rating (1=low 6=high) in Financial sector in 2007 to that in 2009?
Provide a short and direct response. 1.06. What is the ratio of the Rating (1=low 6=high) of Trade in 2007 to that in 2009?
Provide a succinct answer. 0.94. What is the ratio of the Rating (1=low 6=high) of Budget management in 2007 to that in 2009?
Your answer should be very brief. 0.97. What is the ratio of the Rating (1=low 6=high) in Fiscal policy in 2007 to that in 2009?
Provide a short and direct response. 1. What is the ratio of the Rating (1=low 6=high) of Financial sector in 2007 to that in 2010?
Make the answer very short. 1.06. What is the ratio of the Rating (1=low 6=high) of Trade in 2007 to that in 2010?
Your response must be concise. 0.95. What is the ratio of the Rating (1=low 6=high) of Budget management in 2007 to that in 2010?
Your answer should be very brief. 0.97. What is the ratio of the Rating (1=low 6=high) of Fiscal policy in 2007 to that in 2010?
Your answer should be compact. 0.99. What is the ratio of the Rating (1=low 6=high) in Financial sector in 2007 to that in 2011?
Make the answer very short. 1.09. What is the ratio of the Rating (1=low 6=high) of Trade in 2007 to that in 2011?
Ensure brevity in your answer.  0.96. What is the ratio of the Rating (1=low 6=high) in Budget management in 2007 to that in 2011?
Your answer should be compact. 1.03. What is the ratio of the Rating (1=low 6=high) in Fiscal policy in 2007 to that in 2011?
Your response must be concise. 1.06. What is the ratio of the Rating (1=low 6=high) of Financial sector in 2007 to that in 2012?
Give a very brief answer. 1.12. What is the ratio of the Rating (1=low 6=high) of Trade in 2007 to that in 2012?
Offer a very short reply. 0.99. What is the ratio of the Rating (1=low 6=high) of Budget management in 2007 to that in 2012?
Offer a very short reply. 1.04. What is the ratio of the Rating (1=low 6=high) in Fiscal policy in 2007 to that in 2012?
Your answer should be compact. 1.13. What is the ratio of the Rating (1=low 6=high) in Financial sector in 2008 to that in 2009?
Make the answer very short. 1.06. What is the ratio of the Rating (1=low 6=high) in Trade in 2008 to that in 2009?
Provide a succinct answer. 0.96. What is the ratio of the Rating (1=low 6=high) in Budget management in 2008 to that in 2009?
Keep it short and to the point. 0.99. What is the ratio of the Rating (1=low 6=high) in Financial sector in 2008 to that in 2010?
Your answer should be very brief. 1.06. What is the ratio of the Rating (1=low 6=high) in Trade in 2008 to that in 2010?
Keep it short and to the point. 0.98. What is the ratio of the Rating (1=low 6=high) in Budget management in 2008 to that in 2010?
Your response must be concise. 0.99. What is the ratio of the Rating (1=low 6=high) of Fiscal policy in 2008 to that in 2010?
Keep it short and to the point. 0.97. What is the ratio of the Rating (1=low 6=high) of Financial sector in 2008 to that in 2011?
Make the answer very short. 1.09. What is the ratio of the Rating (1=low 6=high) in Budget management in 2008 to that in 2011?
Offer a terse response. 1.05. What is the ratio of the Rating (1=low 6=high) in Fiscal policy in 2008 to that in 2011?
Give a very brief answer. 1.05. What is the ratio of the Rating (1=low 6=high) of Financial sector in 2008 to that in 2012?
Ensure brevity in your answer.  1.12. What is the ratio of the Rating (1=low 6=high) in Trade in 2008 to that in 2012?
Your response must be concise. 1.01. What is the ratio of the Rating (1=low 6=high) of Budget management in 2008 to that in 2012?
Your answer should be compact. 1.05. What is the ratio of the Rating (1=low 6=high) of Fiscal policy in 2008 to that in 2012?
Offer a very short reply. 1.12. What is the ratio of the Rating (1=low 6=high) of Financial sector in 2009 to that in 2010?
Provide a succinct answer. 1. What is the ratio of the Rating (1=low 6=high) of Fiscal policy in 2009 to that in 2010?
Make the answer very short. 0.99. What is the ratio of the Rating (1=low 6=high) in Financial sector in 2009 to that in 2011?
Make the answer very short. 1.03. What is the ratio of the Rating (1=low 6=high) of Trade in 2009 to that in 2011?
Provide a succinct answer. 1.02. What is the ratio of the Rating (1=low 6=high) of Budget management in 2009 to that in 2011?
Provide a succinct answer. 1.06. What is the ratio of the Rating (1=low 6=high) of Fiscal policy in 2009 to that in 2011?
Your answer should be compact. 1.06. What is the ratio of the Rating (1=low 6=high) of Financial sector in 2009 to that in 2012?
Give a very brief answer. 1.05. What is the ratio of the Rating (1=low 6=high) of Budget management in 2009 to that in 2012?
Provide a short and direct response. 1.07. What is the ratio of the Rating (1=low 6=high) in Fiscal policy in 2009 to that in 2012?
Make the answer very short. 1.13. What is the ratio of the Rating (1=low 6=high) in Financial sector in 2010 to that in 2011?
Your response must be concise. 1.03. What is the ratio of the Rating (1=low 6=high) in Trade in 2010 to that in 2011?
Ensure brevity in your answer.  1.01. What is the ratio of the Rating (1=low 6=high) in Budget management in 2010 to that in 2011?
Your answer should be compact. 1.06. What is the ratio of the Rating (1=low 6=high) of Fiscal policy in 2010 to that in 2011?
Your answer should be very brief. 1.08. What is the ratio of the Rating (1=low 6=high) in Financial sector in 2010 to that in 2012?
Give a very brief answer. 1.05. What is the ratio of the Rating (1=low 6=high) in Trade in 2010 to that in 2012?
Keep it short and to the point. 1.04. What is the ratio of the Rating (1=low 6=high) in Budget management in 2010 to that in 2012?
Offer a terse response. 1.07. What is the ratio of the Rating (1=low 6=high) in Fiscal policy in 2010 to that in 2012?
Provide a succinct answer. 1.15. What is the ratio of the Rating (1=low 6=high) in Financial sector in 2011 to that in 2012?
Ensure brevity in your answer.  1.02. What is the ratio of the Rating (1=low 6=high) of Trade in 2011 to that in 2012?
Make the answer very short. 1.02. What is the ratio of the Rating (1=low 6=high) of Budget management in 2011 to that in 2012?
Offer a terse response. 1.01. What is the ratio of the Rating (1=low 6=high) of Fiscal policy in 2011 to that in 2012?
Offer a very short reply. 1.07. What is the difference between the highest and the second highest Rating (1=low 6=high) in Trade?
Offer a terse response. 0.05. What is the difference between the highest and the second highest Rating (1=low 6=high) of Budget management?
Make the answer very short. 0. What is the difference between the highest and the second highest Rating (1=low 6=high) in Fiscal policy?
Your answer should be compact. 0.15. What is the difference between the highest and the lowest Rating (1=low 6=high) of Financial sector?
Offer a terse response. 0.36. What is the difference between the highest and the lowest Rating (1=low 6=high) in Trade?
Keep it short and to the point. 0.37. What is the difference between the highest and the lowest Rating (1=low 6=high) in Budget management?
Offer a very short reply. 0.23. What is the difference between the highest and the lowest Rating (1=low 6=high) in Fiscal policy?
Offer a very short reply. 0.59. 